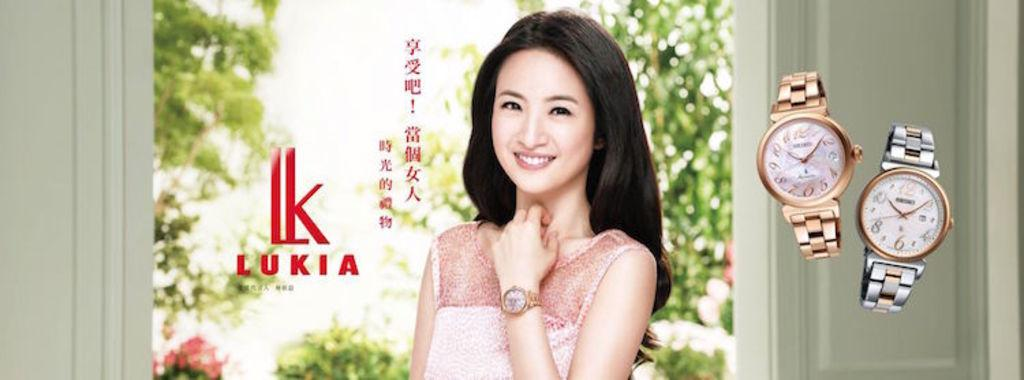<image>
Share a concise interpretation of the image provided. A woman models a Lukia watch while several  others are set to the side for viewing also. 